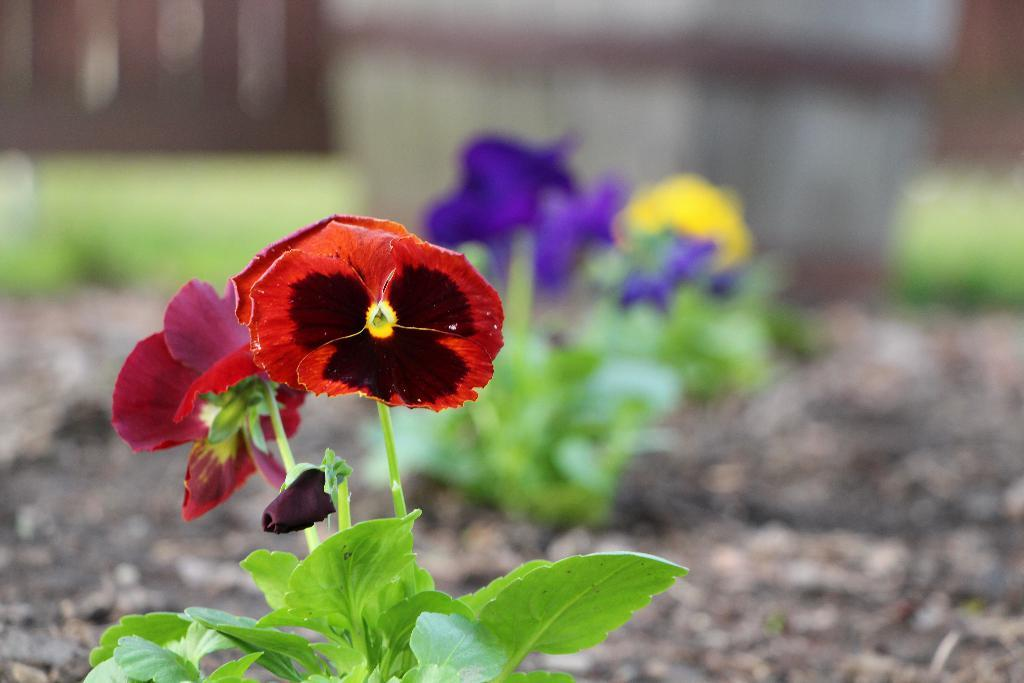What type of living organism is present in the image? There is a plant in the image. What specific features can be observed on the plant? The plant has flowers and green leaves. Can you describe the background of the image? The background of the image is blurred. What type of ring can be seen on the plant in the image? There is no ring present on the plant in the image. 